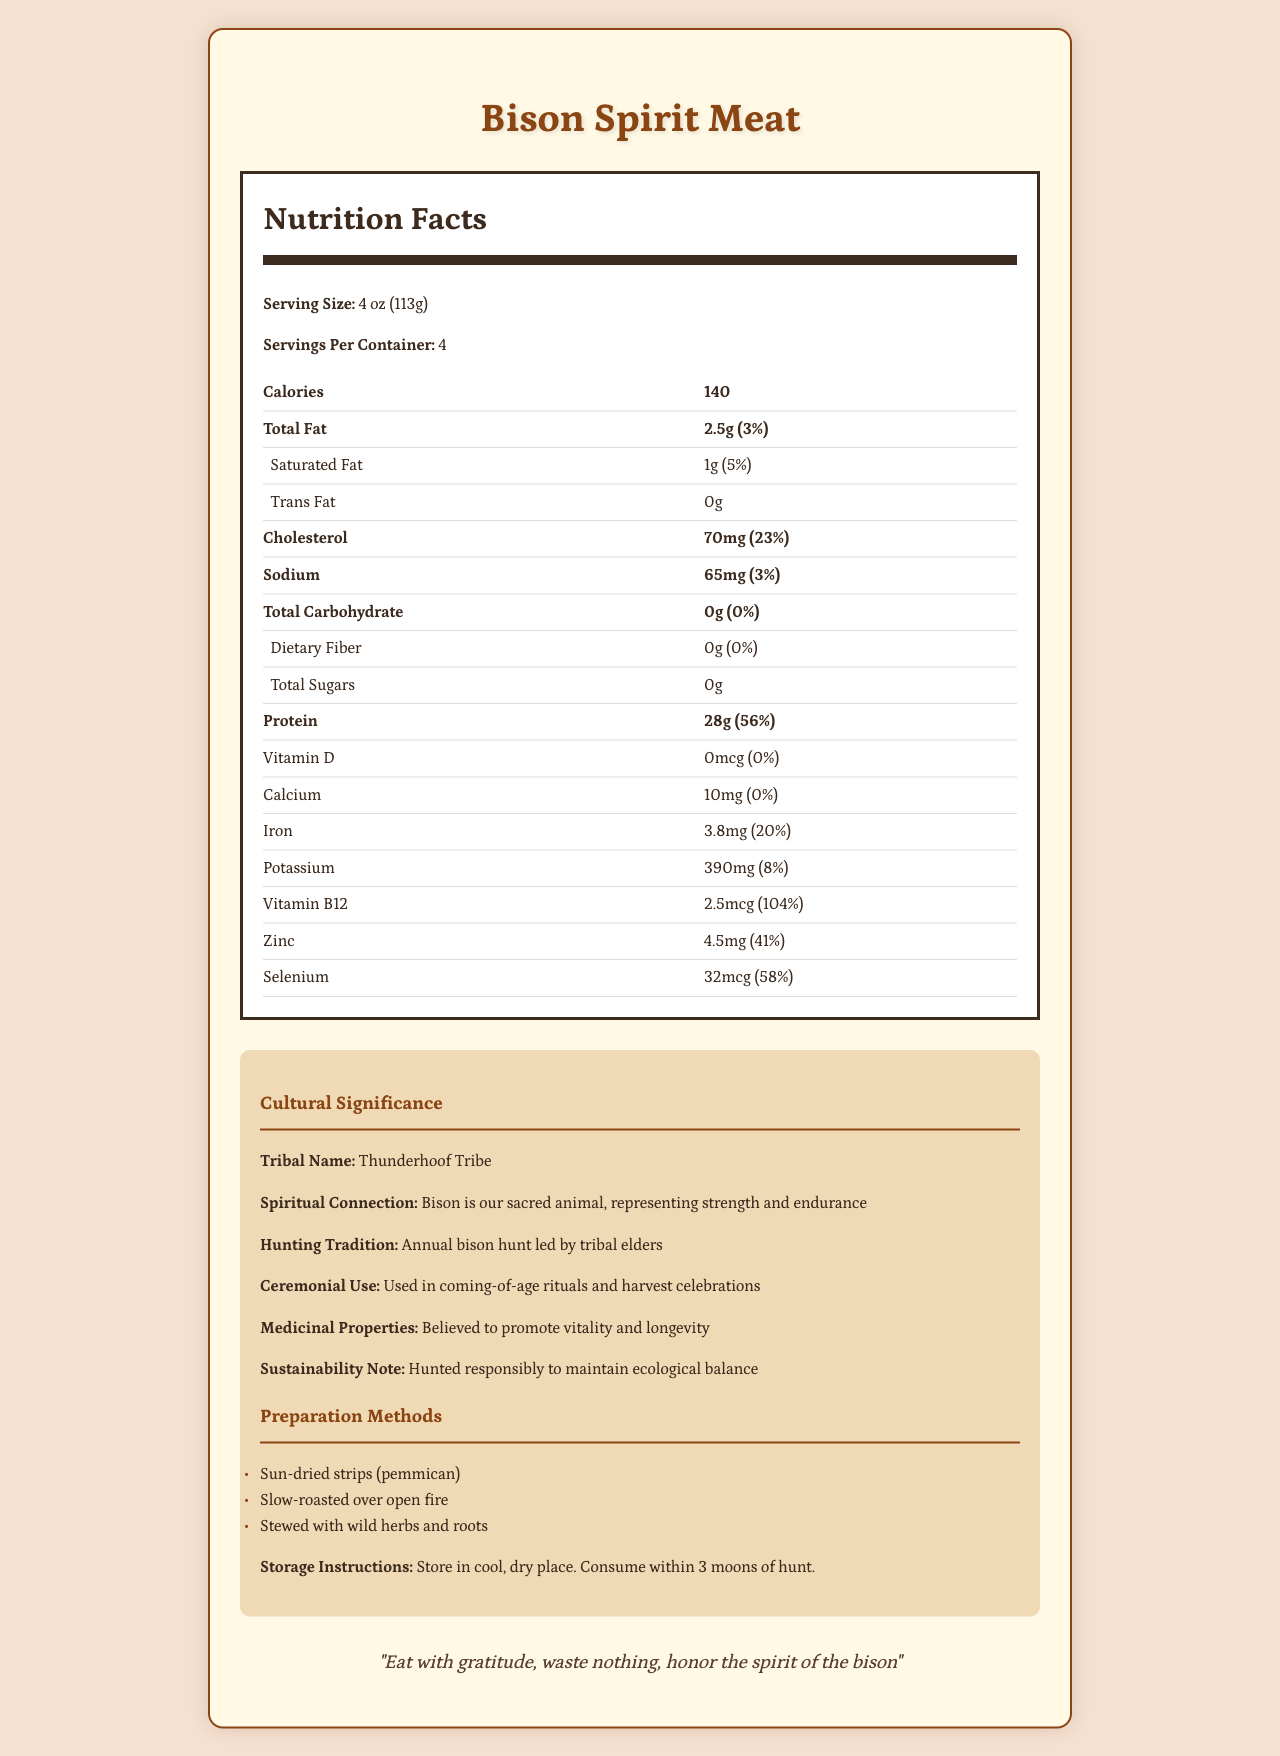what is the serving size for Bison Spirit Meat? The serving size is listed at the beginning of the Nutrition Facts section.
Answer: 4 oz (113g) how many calories are in one serving? The document states that each serving contains 140 calories.
Answer: 140 What is the percentage daily value of Vitamin B12? The document shows that the daily value percentage of Vitamin B12 is 104%.
Answer: 104% how much protein does one serving contain? The amount of protein per serving is indicated in the Nutrition Facts section.
Answer: 28g What are the storage instructions for Bison Spirit Meat? The storage instructions are provided in the cultural section of the document.
Answer: Store in cool, dry place. Consume within 3 moons of hunt. what is the total daily value percentage for iron in one serving? A. 20% B. 25% C. 41% D. 58% The total daily value percentage for iron in one serving is 20%.
Answer: A. 20% Which tribe is associated with the Bison Spirit Meat? I. Oakwood Tribe II. Thunderhoof Tribe III. Forestshade Tribe The document explicitly states that the tribal name is the Thunderhoof Tribe.
Answer: II. Thunderhoof Tribe Is the Bison Spirit Meat high in total sugars? The document shows that the Bison Spirit Meat has 0g of total sugars, indicating it's not high in sugars.
Answer: No Describe the cultural significance of Bison Spirit Meat. The cultural significance section provides detailed information about the cultural and spiritual importance of the bison to the tribe, including its use in traditions and ceremonies.
Answer: Bison Spirit Meat holds significant cultural value for the Thunderhoof Tribe. Bison represent strength and endurance and are used in various traditional practices, including annual hunts, coming-of-age rituals, and harvest celebrations. The meat is also believed to have medicinal properties promoting vitality and longevity. What environmental practices are followed in the hunting of Bison Spirit Meat? The document mentions the meat is hunted responsibly to maintain ecological balance, but it does not detail specific environmental practices followed.
Answer: Not enough information 